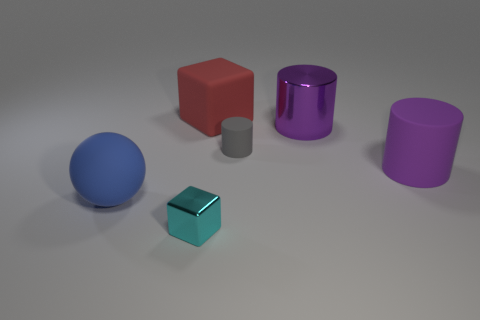Subtract all purple cylinders. How many cylinders are left? 1 Add 2 small cylinders. How many objects exist? 8 Subtract all cyan spheres. How many purple cylinders are left? 2 Subtract all gray cylinders. How many cylinders are left? 2 Subtract all spheres. How many objects are left? 5 Subtract 1 cylinders. How many cylinders are left? 2 Subtract all brown spheres. Subtract all cyan cylinders. How many spheres are left? 1 Subtract all big purple cylinders. Subtract all purple cylinders. How many objects are left? 2 Add 1 big purple objects. How many big purple objects are left? 3 Add 5 tiny metal objects. How many tiny metal objects exist? 6 